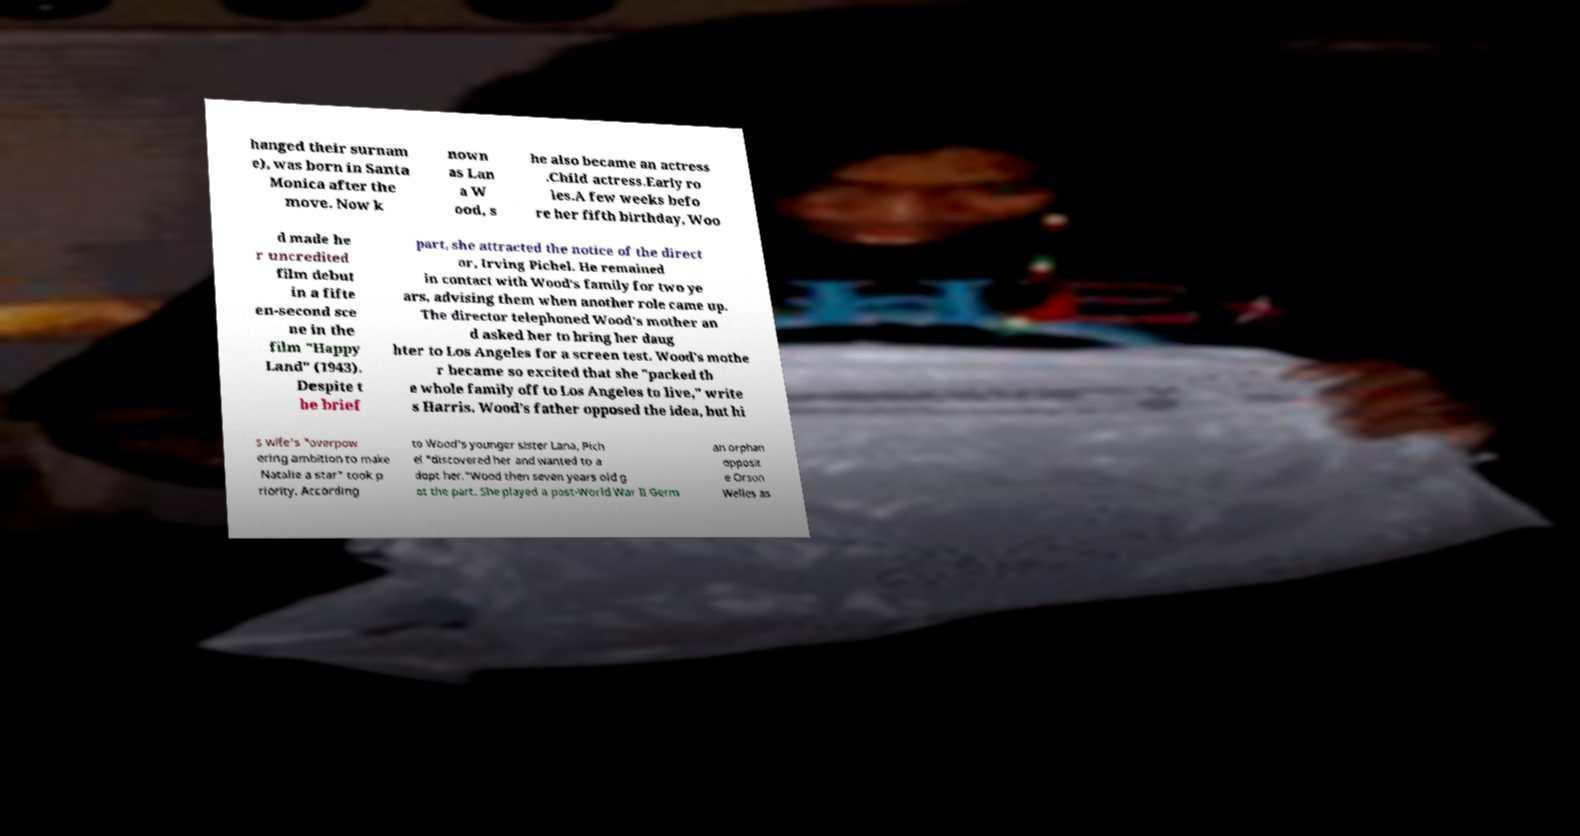Please identify and transcribe the text found in this image. hanged their surnam e), was born in Santa Monica after the move. Now k nown as Lan a W ood, s he also became an actress .Child actress.Early ro les.A few weeks befo re her fifth birthday, Woo d made he r uncredited film debut in a fifte en-second sce ne in the film "Happy Land" (1943). Despite t he brief part, she attracted the notice of the direct or, Irving Pichel. He remained in contact with Wood's family for two ye ars, advising them when another role came up. The director telephoned Wood's mother an d asked her to bring her daug hter to Los Angeles for a screen test. Wood's mothe r became so excited that she "packed th e whole family off to Los Angeles to live," write s Harris. Wood's father opposed the idea, but hi s wife's "overpow ering ambition to make Natalie a star" took p riority. According to Wood's younger sister Lana, Pich el "discovered her and wanted to a dopt her."Wood then seven years old g ot the part. She played a post-World War II Germ an orphan opposit e Orson Welles as 